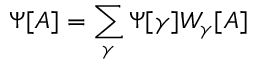Convert formula to latex. <formula><loc_0><loc_0><loc_500><loc_500>\Psi [ A ] = \sum _ { \gamma } \Psi [ \gamma ] W _ { \gamma } [ A ]</formula> 